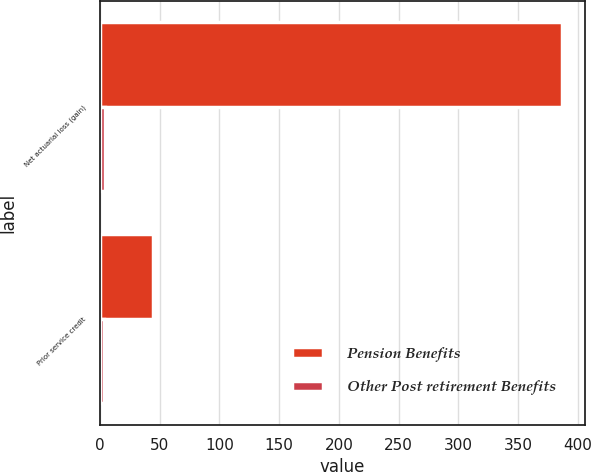<chart> <loc_0><loc_0><loc_500><loc_500><stacked_bar_chart><ecel><fcel>Net actuarial loss (gain)<fcel>Prior service credit<nl><fcel>Pension Benefits<fcel>387<fcel>44<nl><fcel>Other Post retirement Benefits<fcel>4<fcel>3<nl></chart> 